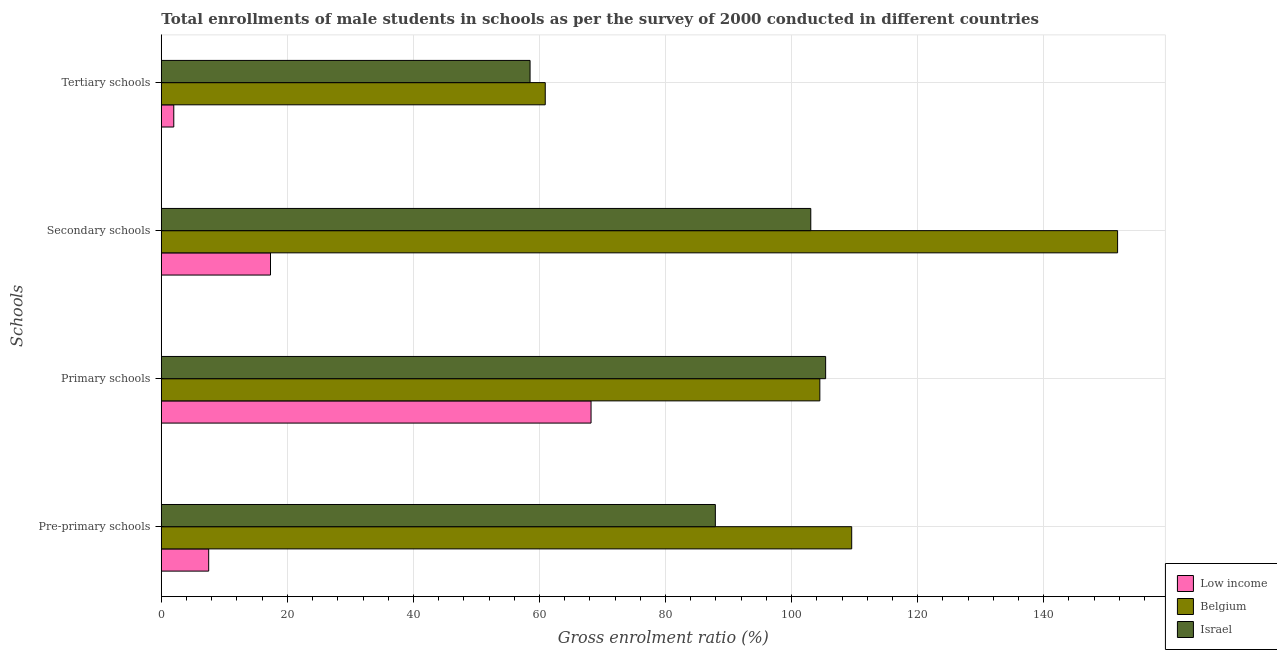How many different coloured bars are there?
Ensure brevity in your answer.  3. Are the number of bars on each tick of the Y-axis equal?
Ensure brevity in your answer.  Yes. How many bars are there on the 1st tick from the top?
Make the answer very short. 3. What is the label of the 2nd group of bars from the top?
Ensure brevity in your answer.  Secondary schools. What is the gross enrolment ratio(male) in primary schools in Israel?
Keep it short and to the point. 105.4. Across all countries, what is the maximum gross enrolment ratio(male) in tertiary schools?
Ensure brevity in your answer.  60.91. Across all countries, what is the minimum gross enrolment ratio(male) in pre-primary schools?
Offer a very short reply. 7.51. In which country was the gross enrolment ratio(male) in secondary schools maximum?
Provide a succinct answer. Belgium. In which country was the gross enrolment ratio(male) in pre-primary schools minimum?
Provide a succinct answer. Low income. What is the total gross enrolment ratio(male) in tertiary schools in the graph?
Your answer should be very brief. 121.39. What is the difference between the gross enrolment ratio(male) in tertiary schools in Israel and that in Belgium?
Keep it short and to the point. -2.41. What is the difference between the gross enrolment ratio(male) in secondary schools in Low income and the gross enrolment ratio(male) in tertiary schools in Israel?
Provide a succinct answer. -41.18. What is the average gross enrolment ratio(male) in tertiary schools per country?
Provide a short and direct response. 40.46. What is the difference between the gross enrolment ratio(male) in tertiary schools and gross enrolment ratio(male) in secondary schools in Belgium?
Give a very brief answer. -90.81. In how many countries, is the gross enrolment ratio(male) in pre-primary schools greater than 12 %?
Offer a very short reply. 2. What is the ratio of the gross enrolment ratio(male) in pre-primary schools in Belgium to that in Israel?
Keep it short and to the point. 1.25. Is the gross enrolment ratio(male) in pre-primary schools in Belgium less than that in Israel?
Offer a terse response. No. What is the difference between the highest and the second highest gross enrolment ratio(male) in pre-primary schools?
Ensure brevity in your answer.  21.64. What is the difference between the highest and the lowest gross enrolment ratio(male) in pre-primary schools?
Provide a short and direct response. 102.02. Is the sum of the gross enrolment ratio(male) in tertiary schools in Low income and Israel greater than the maximum gross enrolment ratio(male) in primary schools across all countries?
Make the answer very short. No. Is it the case that in every country, the sum of the gross enrolment ratio(male) in pre-primary schools and gross enrolment ratio(male) in primary schools is greater than the gross enrolment ratio(male) in secondary schools?
Your answer should be compact. Yes. How many bars are there?
Ensure brevity in your answer.  12. Are all the bars in the graph horizontal?
Give a very brief answer. Yes. How many countries are there in the graph?
Offer a very short reply. 3. What is the difference between two consecutive major ticks on the X-axis?
Your answer should be compact. 20. Are the values on the major ticks of X-axis written in scientific E-notation?
Ensure brevity in your answer.  No. Does the graph contain any zero values?
Provide a succinct answer. No. Where does the legend appear in the graph?
Make the answer very short. Bottom right. How are the legend labels stacked?
Your response must be concise. Vertical. What is the title of the graph?
Provide a succinct answer. Total enrollments of male students in schools as per the survey of 2000 conducted in different countries. Does "Malaysia" appear as one of the legend labels in the graph?
Offer a terse response. No. What is the label or title of the X-axis?
Offer a very short reply. Gross enrolment ratio (%). What is the label or title of the Y-axis?
Offer a terse response. Schools. What is the Gross enrolment ratio (%) of Low income in Pre-primary schools?
Provide a short and direct response. 7.51. What is the Gross enrolment ratio (%) in Belgium in Pre-primary schools?
Ensure brevity in your answer.  109.53. What is the Gross enrolment ratio (%) of Israel in Pre-primary schools?
Your response must be concise. 87.9. What is the Gross enrolment ratio (%) in Low income in Primary schools?
Your answer should be compact. 68.18. What is the Gross enrolment ratio (%) in Belgium in Primary schools?
Offer a terse response. 104.48. What is the Gross enrolment ratio (%) of Israel in Primary schools?
Your answer should be very brief. 105.4. What is the Gross enrolment ratio (%) in Low income in Secondary schools?
Make the answer very short. 17.32. What is the Gross enrolment ratio (%) of Belgium in Secondary schools?
Make the answer very short. 151.72. What is the Gross enrolment ratio (%) of Israel in Secondary schools?
Offer a very short reply. 103.04. What is the Gross enrolment ratio (%) of Low income in Tertiary schools?
Your response must be concise. 1.98. What is the Gross enrolment ratio (%) in Belgium in Tertiary schools?
Ensure brevity in your answer.  60.91. What is the Gross enrolment ratio (%) of Israel in Tertiary schools?
Make the answer very short. 58.5. Across all Schools, what is the maximum Gross enrolment ratio (%) of Low income?
Give a very brief answer. 68.18. Across all Schools, what is the maximum Gross enrolment ratio (%) in Belgium?
Your response must be concise. 151.72. Across all Schools, what is the maximum Gross enrolment ratio (%) in Israel?
Your answer should be very brief. 105.4. Across all Schools, what is the minimum Gross enrolment ratio (%) of Low income?
Provide a short and direct response. 1.98. Across all Schools, what is the minimum Gross enrolment ratio (%) in Belgium?
Ensure brevity in your answer.  60.91. Across all Schools, what is the minimum Gross enrolment ratio (%) in Israel?
Provide a short and direct response. 58.5. What is the total Gross enrolment ratio (%) of Low income in the graph?
Keep it short and to the point. 95. What is the total Gross enrolment ratio (%) of Belgium in the graph?
Provide a short and direct response. 426.64. What is the total Gross enrolment ratio (%) of Israel in the graph?
Provide a short and direct response. 354.84. What is the difference between the Gross enrolment ratio (%) of Low income in Pre-primary schools and that in Primary schools?
Keep it short and to the point. -60.66. What is the difference between the Gross enrolment ratio (%) of Belgium in Pre-primary schools and that in Primary schools?
Your response must be concise. 5.06. What is the difference between the Gross enrolment ratio (%) in Israel in Pre-primary schools and that in Primary schools?
Ensure brevity in your answer.  -17.5. What is the difference between the Gross enrolment ratio (%) in Low income in Pre-primary schools and that in Secondary schools?
Offer a terse response. -9.81. What is the difference between the Gross enrolment ratio (%) in Belgium in Pre-primary schools and that in Secondary schools?
Keep it short and to the point. -42.18. What is the difference between the Gross enrolment ratio (%) of Israel in Pre-primary schools and that in Secondary schools?
Ensure brevity in your answer.  -15.14. What is the difference between the Gross enrolment ratio (%) of Low income in Pre-primary schools and that in Tertiary schools?
Make the answer very short. 5.54. What is the difference between the Gross enrolment ratio (%) in Belgium in Pre-primary schools and that in Tertiary schools?
Your response must be concise. 48.62. What is the difference between the Gross enrolment ratio (%) in Israel in Pre-primary schools and that in Tertiary schools?
Your response must be concise. 29.39. What is the difference between the Gross enrolment ratio (%) of Low income in Primary schools and that in Secondary schools?
Give a very brief answer. 50.86. What is the difference between the Gross enrolment ratio (%) of Belgium in Primary schools and that in Secondary schools?
Give a very brief answer. -47.24. What is the difference between the Gross enrolment ratio (%) in Israel in Primary schools and that in Secondary schools?
Provide a succinct answer. 2.36. What is the difference between the Gross enrolment ratio (%) in Low income in Primary schools and that in Tertiary schools?
Ensure brevity in your answer.  66.2. What is the difference between the Gross enrolment ratio (%) of Belgium in Primary schools and that in Tertiary schools?
Keep it short and to the point. 43.57. What is the difference between the Gross enrolment ratio (%) of Israel in Primary schools and that in Tertiary schools?
Your response must be concise. 46.89. What is the difference between the Gross enrolment ratio (%) of Low income in Secondary schools and that in Tertiary schools?
Provide a short and direct response. 15.34. What is the difference between the Gross enrolment ratio (%) in Belgium in Secondary schools and that in Tertiary schools?
Provide a short and direct response. 90.81. What is the difference between the Gross enrolment ratio (%) of Israel in Secondary schools and that in Tertiary schools?
Your answer should be compact. 44.54. What is the difference between the Gross enrolment ratio (%) of Low income in Pre-primary schools and the Gross enrolment ratio (%) of Belgium in Primary schools?
Provide a succinct answer. -96.96. What is the difference between the Gross enrolment ratio (%) of Low income in Pre-primary schools and the Gross enrolment ratio (%) of Israel in Primary schools?
Keep it short and to the point. -97.88. What is the difference between the Gross enrolment ratio (%) of Belgium in Pre-primary schools and the Gross enrolment ratio (%) of Israel in Primary schools?
Keep it short and to the point. 4.14. What is the difference between the Gross enrolment ratio (%) of Low income in Pre-primary schools and the Gross enrolment ratio (%) of Belgium in Secondary schools?
Ensure brevity in your answer.  -144.2. What is the difference between the Gross enrolment ratio (%) of Low income in Pre-primary schools and the Gross enrolment ratio (%) of Israel in Secondary schools?
Offer a terse response. -95.53. What is the difference between the Gross enrolment ratio (%) of Belgium in Pre-primary schools and the Gross enrolment ratio (%) of Israel in Secondary schools?
Offer a terse response. 6.49. What is the difference between the Gross enrolment ratio (%) of Low income in Pre-primary schools and the Gross enrolment ratio (%) of Belgium in Tertiary schools?
Your answer should be very brief. -53.4. What is the difference between the Gross enrolment ratio (%) in Low income in Pre-primary schools and the Gross enrolment ratio (%) in Israel in Tertiary schools?
Provide a short and direct response. -50.99. What is the difference between the Gross enrolment ratio (%) in Belgium in Pre-primary schools and the Gross enrolment ratio (%) in Israel in Tertiary schools?
Offer a very short reply. 51.03. What is the difference between the Gross enrolment ratio (%) in Low income in Primary schools and the Gross enrolment ratio (%) in Belgium in Secondary schools?
Offer a terse response. -83.54. What is the difference between the Gross enrolment ratio (%) in Low income in Primary schools and the Gross enrolment ratio (%) in Israel in Secondary schools?
Make the answer very short. -34.86. What is the difference between the Gross enrolment ratio (%) in Belgium in Primary schools and the Gross enrolment ratio (%) in Israel in Secondary schools?
Offer a terse response. 1.44. What is the difference between the Gross enrolment ratio (%) in Low income in Primary schools and the Gross enrolment ratio (%) in Belgium in Tertiary schools?
Your answer should be compact. 7.27. What is the difference between the Gross enrolment ratio (%) of Low income in Primary schools and the Gross enrolment ratio (%) of Israel in Tertiary schools?
Offer a terse response. 9.68. What is the difference between the Gross enrolment ratio (%) in Belgium in Primary schools and the Gross enrolment ratio (%) in Israel in Tertiary schools?
Your answer should be very brief. 45.97. What is the difference between the Gross enrolment ratio (%) in Low income in Secondary schools and the Gross enrolment ratio (%) in Belgium in Tertiary schools?
Make the answer very short. -43.59. What is the difference between the Gross enrolment ratio (%) in Low income in Secondary schools and the Gross enrolment ratio (%) in Israel in Tertiary schools?
Your response must be concise. -41.18. What is the difference between the Gross enrolment ratio (%) in Belgium in Secondary schools and the Gross enrolment ratio (%) in Israel in Tertiary schools?
Offer a very short reply. 93.21. What is the average Gross enrolment ratio (%) in Low income per Schools?
Offer a very short reply. 23.75. What is the average Gross enrolment ratio (%) in Belgium per Schools?
Give a very brief answer. 106.66. What is the average Gross enrolment ratio (%) of Israel per Schools?
Your answer should be compact. 88.71. What is the difference between the Gross enrolment ratio (%) in Low income and Gross enrolment ratio (%) in Belgium in Pre-primary schools?
Ensure brevity in your answer.  -102.02. What is the difference between the Gross enrolment ratio (%) in Low income and Gross enrolment ratio (%) in Israel in Pre-primary schools?
Your answer should be very brief. -80.38. What is the difference between the Gross enrolment ratio (%) of Belgium and Gross enrolment ratio (%) of Israel in Pre-primary schools?
Provide a succinct answer. 21.64. What is the difference between the Gross enrolment ratio (%) of Low income and Gross enrolment ratio (%) of Belgium in Primary schools?
Give a very brief answer. -36.3. What is the difference between the Gross enrolment ratio (%) of Low income and Gross enrolment ratio (%) of Israel in Primary schools?
Ensure brevity in your answer.  -37.22. What is the difference between the Gross enrolment ratio (%) in Belgium and Gross enrolment ratio (%) in Israel in Primary schools?
Make the answer very short. -0.92. What is the difference between the Gross enrolment ratio (%) of Low income and Gross enrolment ratio (%) of Belgium in Secondary schools?
Your response must be concise. -134.39. What is the difference between the Gross enrolment ratio (%) of Low income and Gross enrolment ratio (%) of Israel in Secondary schools?
Offer a terse response. -85.72. What is the difference between the Gross enrolment ratio (%) in Belgium and Gross enrolment ratio (%) in Israel in Secondary schools?
Your answer should be very brief. 48.68. What is the difference between the Gross enrolment ratio (%) of Low income and Gross enrolment ratio (%) of Belgium in Tertiary schools?
Give a very brief answer. -58.93. What is the difference between the Gross enrolment ratio (%) of Low income and Gross enrolment ratio (%) of Israel in Tertiary schools?
Offer a terse response. -56.52. What is the difference between the Gross enrolment ratio (%) in Belgium and Gross enrolment ratio (%) in Israel in Tertiary schools?
Your answer should be very brief. 2.41. What is the ratio of the Gross enrolment ratio (%) in Low income in Pre-primary schools to that in Primary schools?
Provide a short and direct response. 0.11. What is the ratio of the Gross enrolment ratio (%) in Belgium in Pre-primary schools to that in Primary schools?
Your answer should be very brief. 1.05. What is the ratio of the Gross enrolment ratio (%) of Israel in Pre-primary schools to that in Primary schools?
Your answer should be compact. 0.83. What is the ratio of the Gross enrolment ratio (%) of Low income in Pre-primary schools to that in Secondary schools?
Your answer should be very brief. 0.43. What is the ratio of the Gross enrolment ratio (%) in Belgium in Pre-primary schools to that in Secondary schools?
Ensure brevity in your answer.  0.72. What is the ratio of the Gross enrolment ratio (%) of Israel in Pre-primary schools to that in Secondary schools?
Your response must be concise. 0.85. What is the ratio of the Gross enrolment ratio (%) in Low income in Pre-primary schools to that in Tertiary schools?
Your answer should be very brief. 3.8. What is the ratio of the Gross enrolment ratio (%) in Belgium in Pre-primary schools to that in Tertiary schools?
Your answer should be very brief. 1.8. What is the ratio of the Gross enrolment ratio (%) in Israel in Pre-primary schools to that in Tertiary schools?
Provide a succinct answer. 1.5. What is the ratio of the Gross enrolment ratio (%) of Low income in Primary schools to that in Secondary schools?
Offer a very short reply. 3.94. What is the ratio of the Gross enrolment ratio (%) of Belgium in Primary schools to that in Secondary schools?
Offer a terse response. 0.69. What is the ratio of the Gross enrolment ratio (%) of Israel in Primary schools to that in Secondary schools?
Your response must be concise. 1.02. What is the ratio of the Gross enrolment ratio (%) of Low income in Primary schools to that in Tertiary schools?
Offer a terse response. 34.45. What is the ratio of the Gross enrolment ratio (%) in Belgium in Primary schools to that in Tertiary schools?
Make the answer very short. 1.72. What is the ratio of the Gross enrolment ratio (%) in Israel in Primary schools to that in Tertiary schools?
Your response must be concise. 1.8. What is the ratio of the Gross enrolment ratio (%) of Low income in Secondary schools to that in Tertiary schools?
Your answer should be compact. 8.75. What is the ratio of the Gross enrolment ratio (%) in Belgium in Secondary schools to that in Tertiary schools?
Ensure brevity in your answer.  2.49. What is the ratio of the Gross enrolment ratio (%) in Israel in Secondary schools to that in Tertiary schools?
Your answer should be very brief. 1.76. What is the difference between the highest and the second highest Gross enrolment ratio (%) of Low income?
Give a very brief answer. 50.86. What is the difference between the highest and the second highest Gross enrolment ratio (%) in Belgium?
Give a very brief answer. 42.18. What is the difference between the highest and the second highest Gross enrolment ratio (%) in Israel?
Your answer should be very brief. 2.36. What is the difference between the highest and the lowest Gross enrolment ratio (%) in Low income?
Ensure brevity in your answer.  66.2. What is the difference between the highest and the lowest Gross enrolment ratio (%) of Belgium?
Offer a terse response. 90.81. What is the difference between the highest and the lowest Gross enrolment ratio (%) of Israel?
Keep it short and to the point. 46.89. 